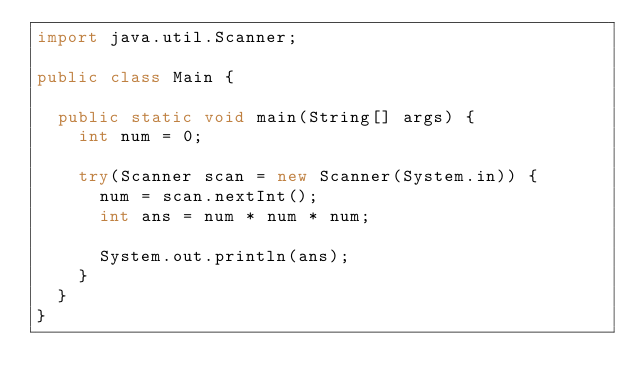<code> <loc_0><loc_0><loc_500><loc_500><_Java_>import java.util.Scanner;

public class Main {

	public static void main(String[] args) {
		int num = 0;

		try(Scanner scan = new Scanner(System.in)) {
			num = scan.nextInt();
			int ans = num * num * num;

			System.out.println(ans);
		}
	}
}</code> 